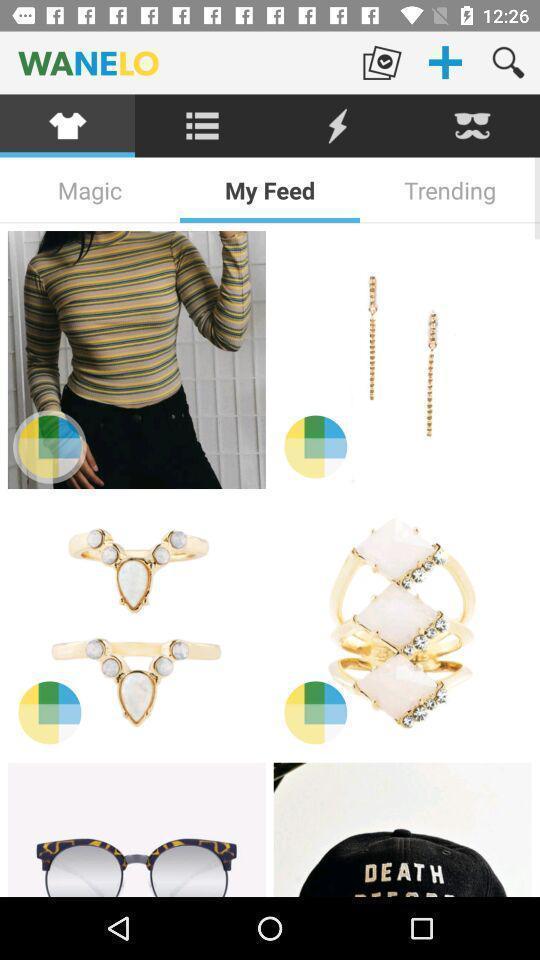Explain the elements present in this screenshot. Various products in shopping app. 